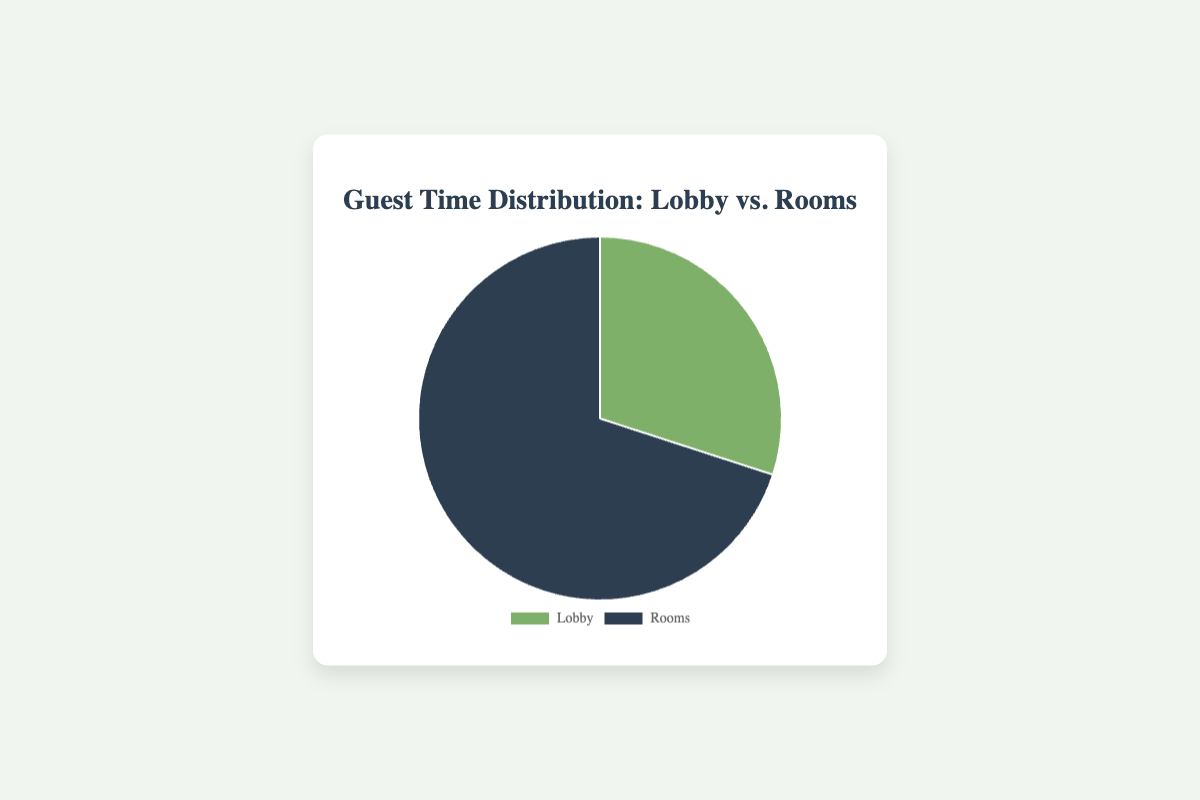what are the percentages of time spent in the lobby and rooms? The pie chart shows that 30% of the time is spent in the lobby and 70% in the rooms.
Answer: 30% in the lobby and 70% in rooms Which area do guests spend more time in? According to the pie chart, guests spend more time in rooms (70%) compared to the lobby (30%).
Answer: rooms By what percentage is the time spent in rooms greater than the lobby? The time spent in rooms is 70% and in the lobby is 30%. The difference is 70% - 30% = 40%.
Answer: 40% What fraction of the total time is spent in the lobby? The time spent in the lobby is 30%. As a fraction of 100%, this is 30/100 = 3/10 or 0.3.
Answer: 0.3 How many times greater is the percentage of time spent in rooms compared to the lobby? The time spent in rooms is 70% and in the lobby is 30%. To find how many times greater, divide 70 by 30, which is approximately 2.33 times greater.
Answer: 2.33 times What are the colors representing the lobby and rooms in the pie chart? The pie chart uses a green shade to represent the lobby and a darker color (likely grey) to represent the rooms.
Answer: green for lobby, grey for rooms If the total time is divided into 10 hours, how many hours are spent in the lobby and how many in the rooms? 30% of 10 hours is spent in the lobby and 70% in the rooms. 30% of 10 hours is 3 hours (0.3 * 10) in the lobby, and 70% of 10 hours is 7 hours (0.7 * 10) in the rooms.
Answer: 3 hours in lobby, 7 hours in rooms If you consider adding another location where guests spend 20% of their time, how would this affect the percentages of time spent in the lobby and rooms? Adding another location with 20% would mean redistributing the remaining 80% between the lobby and rooms. Assuming an even distribution in the original percentages, the lobby would now be 24% (30% of 80%) and rooms 56% (70% of 80%).
Answer: 24% lobby, 56% rooms What is the combined time percentage spent by guests in either the lobby or the rooms? The time spent in either the lobby or the rooms would be the total percentage, which is 30% (lobby) + 70% (rooms).
Answer: 100% 